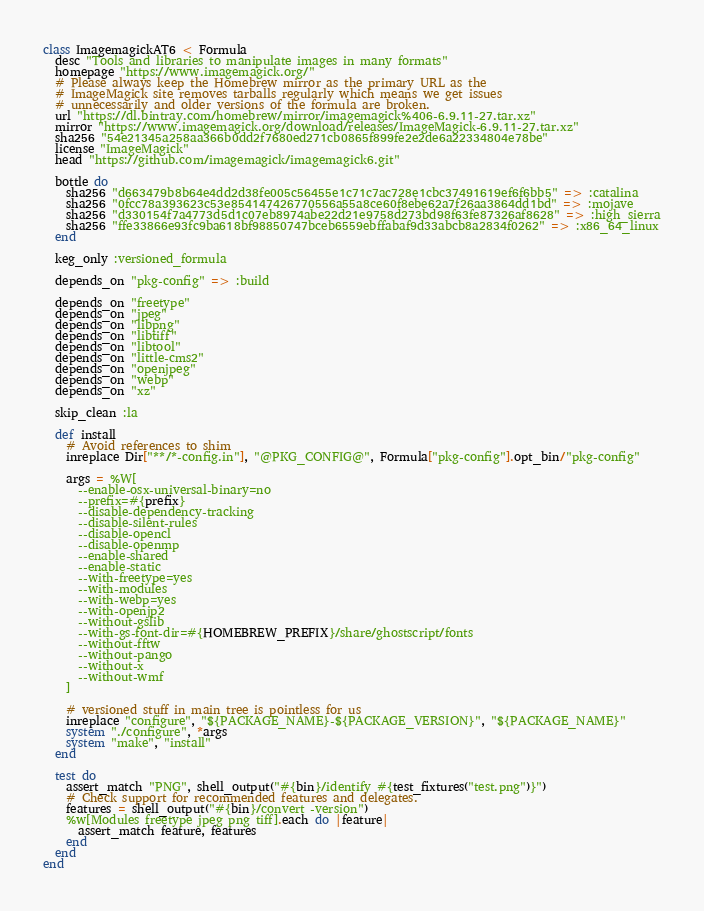Convert code to text. <code><loc_0><loc_0><loc_500><loc_500><_Ruby_>class ImagemagickAT6 < Formula
  desc "Tools and libraries to manipulate images in many formats"
  homepage "https://www.imagemagick.org/"
  # Please always keep the Homebrew mirror as the primary URL as the
  # ImageMagick site removes tarballs regularly which means we get issues
  # unnecessarily and older versions of the formula are broken.
  url "https://dl.bintray.com/homebrew/mirror/imagemagick%406-6.9.11-27.tar.xz"
  mirror "https://www.imagemagick.org/download/releases/ImageMagick-6.9.11-27.tar.xz"
  sha256 "54e21345a258aa366b0dd2f7680ed271cb0865f899fe2e2de6a22334804e78be"
  license "ImageMagick"
  head "https://github.com/imagemagick/imagemagick6.git"

  bottle do
    sha256 "d663479b8b64e4dd2d38fe005c56455e1c71c7ac728e1cbc37491619ef6f6bb5" => :catalina
    sha256 "0fcc78a393623c53e854147426770556a55a8ce60f8ebe62a7f26aa3864dd1bd" => :mojave
    sha256 "d330154f7a4773d5d1c07eb8974abe22d21e9758d273bd98f63fe87326af8628" => :high_sierra
    sha256 "ffe33866e93fc9ba618bf98850747bceb6559ebffabaf9d33abcb8a2834f0262" => :x86_64_linux
  end

  keg_only :versioned_formula

  depends_on "pkg-config" => :build

  depends_on "freetype"
  depends_on "jpeg"
  depends_on "libpng"
  depends_on "libtiff"
  depends_on "libtool"
  depends_on "little-cms2"
  depends_on "openjpeg"
  depends_on "webp"
  depends_on "xz"

  skip_clean :la

  def install
    # Avoid references to shim
    inreplace Dir["**/*-config.in"], "@PKG_CONFIG@", Formula["pkg-config"].opt_bin/"pkg-config"

    args = %W[
      --enable-osx-universal-binary=no
      --prefix=#{prefix}
      --disable-dependency-tracking
      --disable-silent-rules
      --disable-opencl
      --disable-openmp
      --enable-shared
      --enable-static
      --with-freetype=yes
      --with-modules
      --with-webp=yes
      --with-openjp2
      --without-gslib
      --with-gs-font-dir=#{HOMEBREW_PREFIX}/share/ghostscript/fonts
      --without-fftw
      --without-pango
      --without-x
      --without-wmf
    ]

    # versioned stuff in main tree is pointless for us
    inreplace "configure", "${PACKAGE_NAME}-${PACKAGE_VERSION}", "${PACKAGE_NAME}"
    system "./configure", *args
    system "make", "install"
  end

  test do
    assert_match "PNG", shell_output("#{bin}/identify #{test_fixtures("test.png")}")
    # Check support for recommended features and delegates.
    features = shell_output("#{bin}/convert -version")
    %w[Modules freetype jpeg png tiff].each do |feature|
      assert_match feature, features
    end
  end
end
</code> 